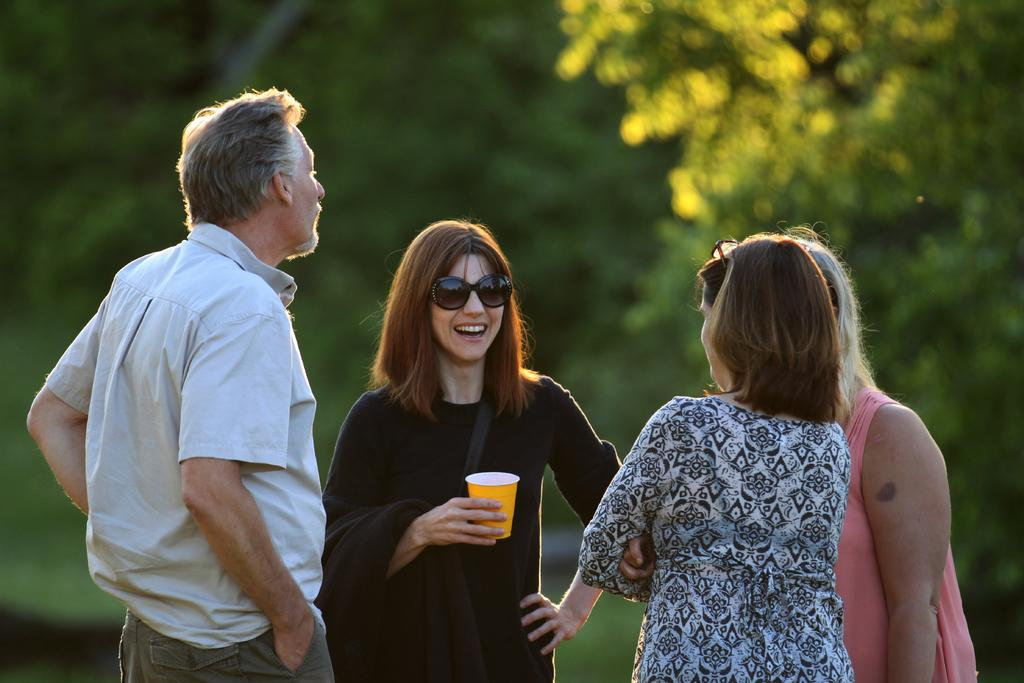What is the main subject of the image? The main subject of the image is a group of people. Where are the people located in the image? The group of people is in the middle of the image. What can be seen in the background of the image? There are trees in the background of the image. What type of grape is being used as a hat by one of the people in the image? There is no grape present in the image, and no one is wearing a grape as a hat. 